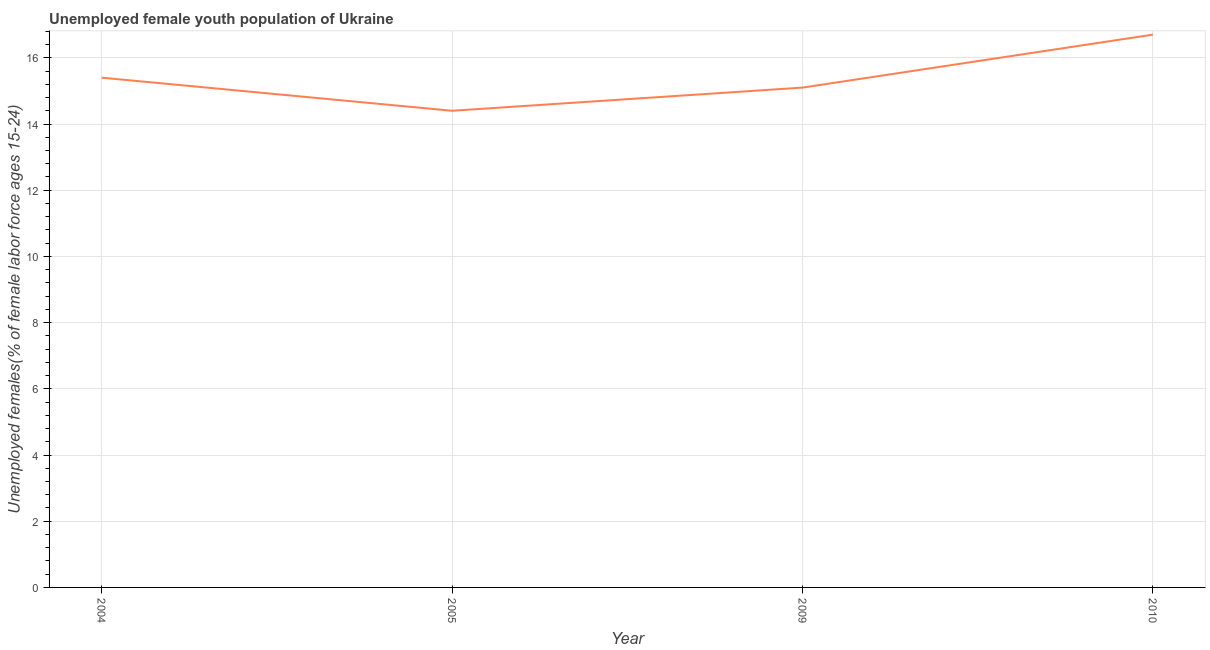What is the unemployed female youth in 2009?
Offer a terse response. 15.1. Across all years, what is the maximum unemployed female youth?
Your answer should be compact. 16.7. Across all years, what is the minimum unemployed female youth?
Give a very brief answer. 14.4. In which year was the unemployed female youth minimum?
Provide a short and direct response. 2005. What is the sum of the unemployed female youth?
Ensure brevity in your answer.  61.6. What is the difference between the unemployed female youth in 2005 and 2009?
Offer a very short reply. -0.7. What is the average unemployed female youth per year?
Your answer should be compact. 15.4. What is the median unemployed female youth?
Ensure brevity in your answer.  15.25. In how many years, is the unemployed female youth greater than 0.8 %?
Your response must be concise. 4. What is the ratio of the unemployed female youth in 2009 to that in 2010?
Ensure brevity in your answer.  0.9. Is the unemployed female youth in 2009 less than that in 2010?
Keep it short and to the point. Yes. What is the difference between the highest and the second highest unemployed female youth?
Keep it short and to the point. 1.3. What is the difference between the highest and the lowest unemployed female youth?
Ensure brevity in your answer.  2.3. Does the unemployed female youth monotonically increase over the years?
Provide a short and direct response. No. How many lines are there?
Your response must be concise. 1. How many years are there in the graph?
Ensure brevity in your answer.  4. Does the graph contain any zero values?
Your answer should be compact. No. Does the graph contain grids?
Give a very brief answer. Yes. What is the title of the graph?
Your response must be concise. Unemployed female youth population of Ukraine. What is the label or title of the X-axis?
Your answer should be very brief. Year. What is the label or title of the Y-axis?
Offer a terse response. Unemployed females(% of female labor force ages 15-24). What is the Unemployed females(% of female labor force ages 15-24) in 2004?
Ensure brevity in your answer.  15.4. What is the Unemployed females(% of female labor force ages 15-24) in 2005?
Make the answer very short. 14.4. What is the Unemployed females(% of female labor force ages 15-24) of 2009?
Provide a short and direct response. 15.1. What is the Unemployed females(% of female labor force ages 15-24) in 2010?
Your answer should be compact. 16.7. What is the difference between the Unemployed females(% of female labor force ages 15-24) in 2004 and 2005?
Provide a short and direct response. 1. What is the difference between the Unemployed females(% of female labor force ages 15-24) in 2004 and 2009?
Offer a terse response. 0.3. What is the difference between the Unemployed females(% of female labor force ages 15-24) in 2004 and 2010?
Your response must be concise. -1.3. What is the difference between the Unemployed females(% of female labor force ages 15-24) in 2009 and 2010?
Ensure brevity in your answer.  -1.6. What is the ratio of the Unemployed females(% of female labor force ages 15-24) in 2004 to that in 2005?
Offer a very short reply. 1.07. What is the ratio of the Unemployed females(% of female labor force ages 15-24) in 2004 to that in 2009?
Offer a very short reply. 1.02. What is the ratio of the Unemployed females(% of female labor force ages 15-24) in 2004 to that in 2010?
Offer a very short reply. 0.92. What is the ratio of the Unemployed females(% of female labor force ages 15-24) in 2005 to that in 2009?
Your answer should be very brief. 0.95. What is the ratio of the Unemployed females(% of female labor force ages 15-24) in 2005 to that in 2010?
Your response must be concise. 0.86. What is the ratio of the Unemployed females(% of female labor force ages 15-24) in 2009 to that in 2010?
Your answer should be very brief. 0.9. 